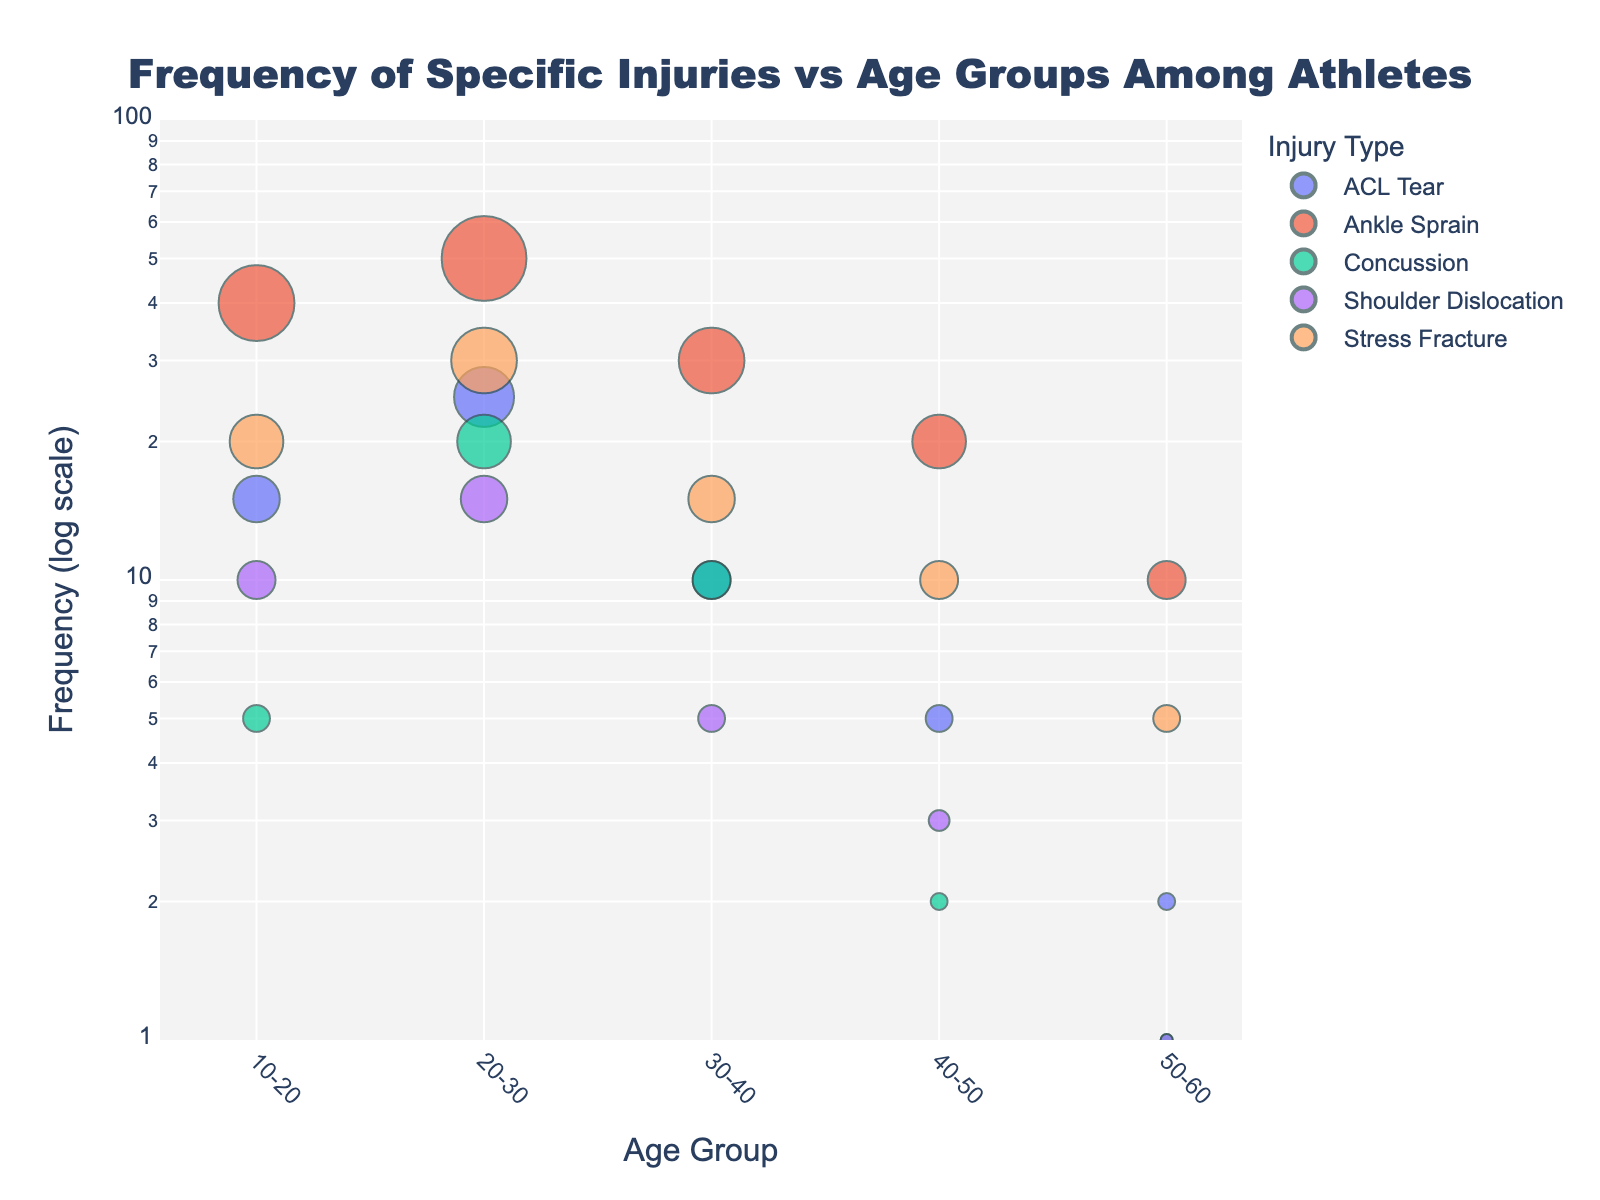What is the title of the scatter plot? The title of the scatter plot appears at the top of the figure, centered and in a larger font size compared to the rest of the text.
Answer: Frequency of Specific Injuries vs Age Groups Among Athletes What are the five different injury types shown in the scatter plot? The injury types can be identified through the legend on the right side of the scatter plot.
Answer: ACL Tear, Ankle Sprain, Concussion, Shoulder Dislocation, Stress Fracture Which age group has the highest frequency of ankle sprains, and what is that frequency? The highest frequency can be identified by locating the largest marker corresponding to ankle sprains in the plot. This occurs at the age group 20-30.
Answer: 20-30, 50 Comparing ACL Tears, which age group has the least frequency? To find the least frequency, look for the smallest marker corresponding to ACL Tears on the scatter plot. The age group 50-60 has the smallest marker.
Answer: 50-60 How does the frequency of concussions in the 40-50 age group compare to the 50-60 age group? Locate the markers for concussions in both the 40-50 and 50-60 age groups. The marker for 40-50 is larger than that for 50-60.
Answer: 40-50 is higher than 50-60 Which age group shows a higher frequency of shoulder dislocations: 10-20 or 20-30? Compare the markers for shoulder dislocations between these two age groups. The 20-30 group has a larger marker.
Answer: 20-30 Among the 30-40 age group, which injury type has the highest frequency? In the 30-40 age group, find the marker with the largest size to identify the injury type.
Answer: Ankle Sprain Calculate the average frequency of ACL Tears across all age groups. Sum the frequencies (15 + 25 + 10 + 5 + 2) and divide by the number of age groups (5). The total is 57, and the average is 57/5.
Answer: 11.4 Between stress fracture and concussion, which injury type has a higher frequency in the 20-30 age group? Compare the markers for both injury types in the 20-30 age group. Stress Fracture has a larger marker compared to Concussion.
Answer: Stress Fracture What pattern do you observe in the frequency of ankle sprains as age increases? Observing the scatter plot, we see the frequency of ankle sprains decreases consistently as age increases from 10-20 to 50-60.
Answer: Decreases 